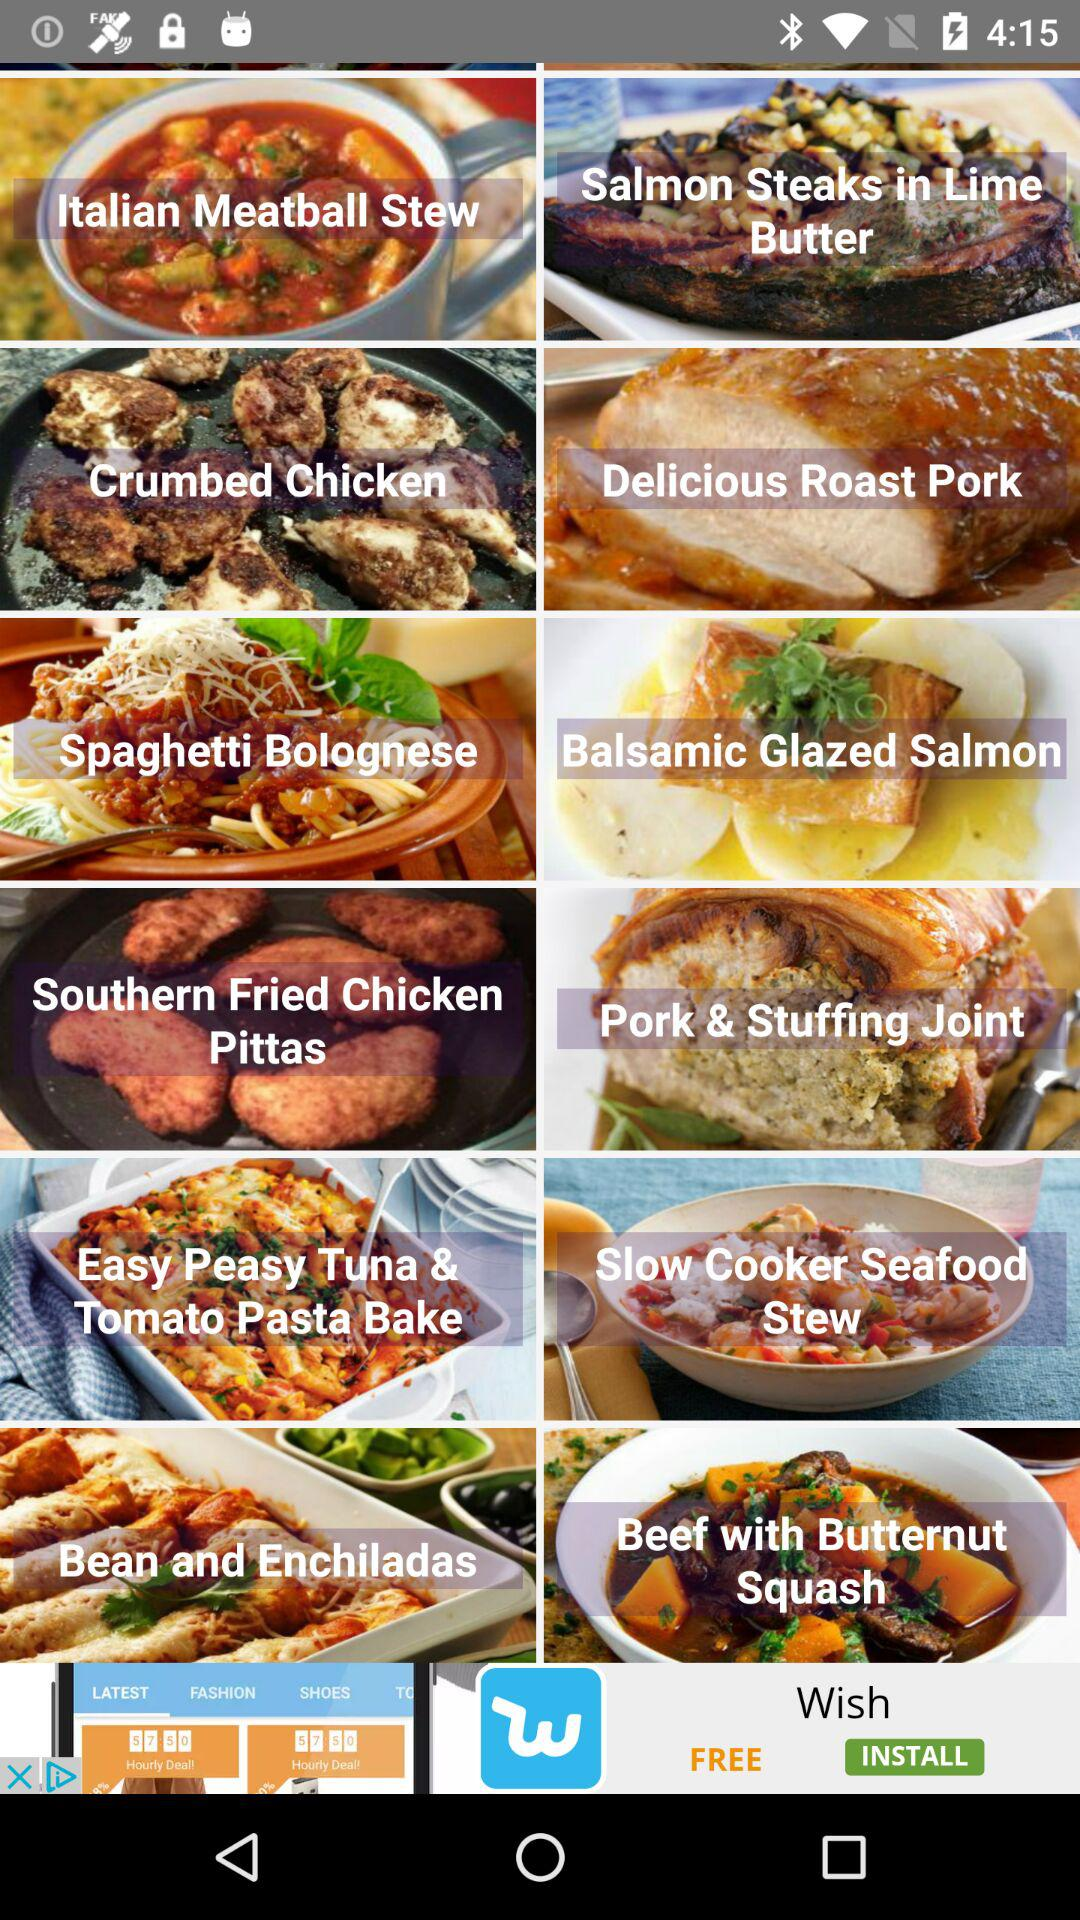How many more recipes are there for pasta than for chicken?
Answer the question using a single word or phrase. 1 